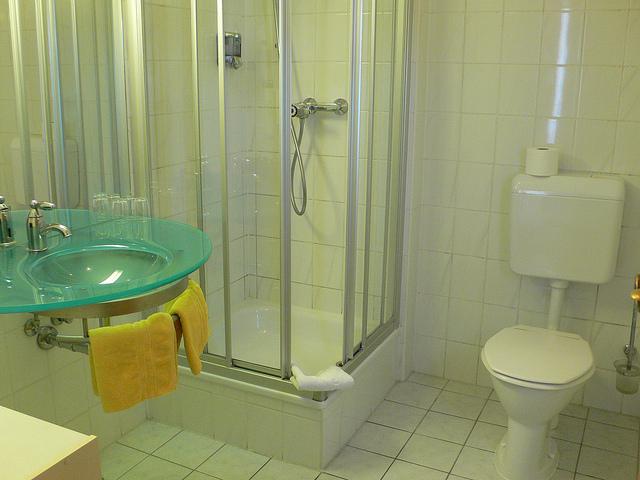Is there a shower in this room?
Short answer required. Yes. Does this restroom usually get used by a child?
Quick response, please. No. Are there towels under the sink?
Be succinct. Yes. What color is the sink bowl?
Answer briefly. Green. 